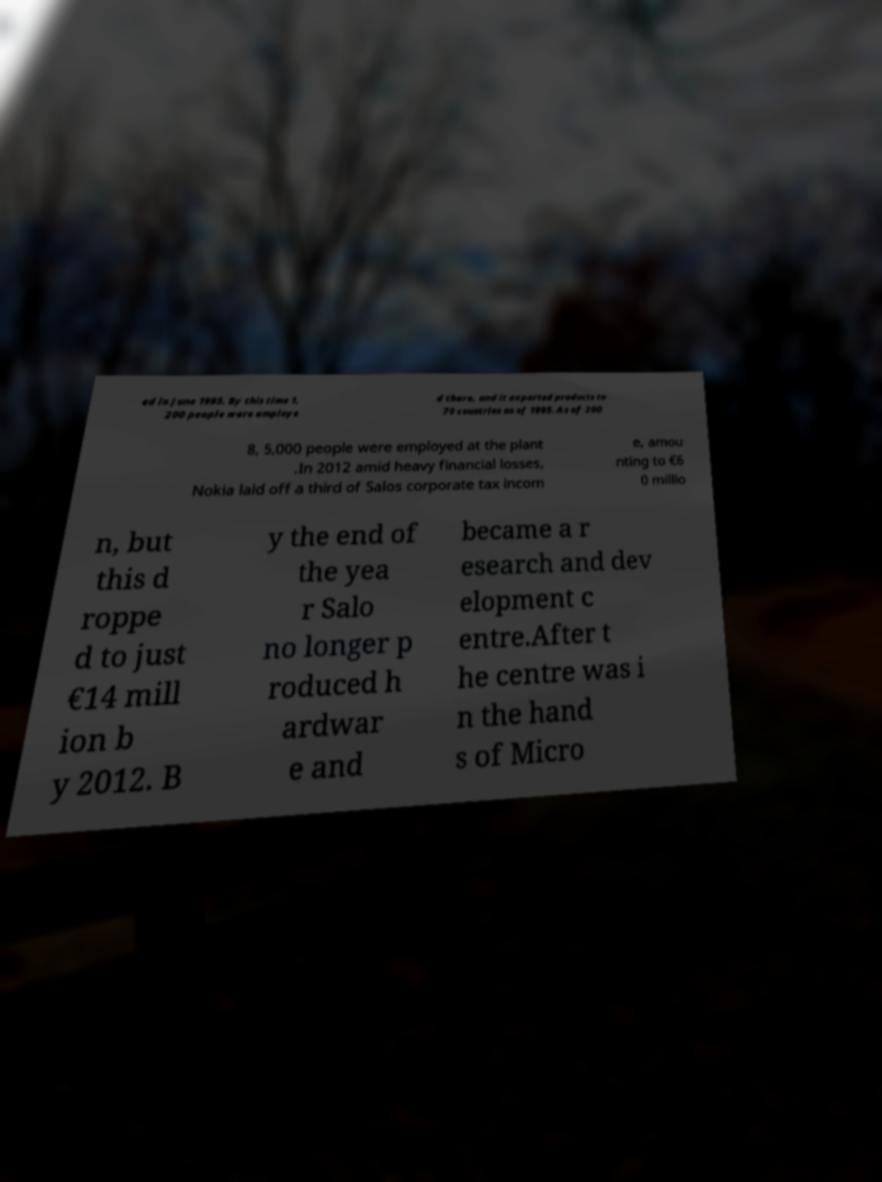What messages or text are displayed in this image? I need them in a readable, typed format. ed in June 1995. By this time 1, 200 people were employe d there, and it exported products to 70 countries as of 1995. As of 200 8, 5,000 people were employed at the plant .In 2012 amid heavy financial losses, Nokia laid off a third of Salos corporate tax incom e, amou nting to €6 0 millio n, but this d roppe d to just €14 mill ion b y 2012. B y the end of the yea r Salo no longer p roduced h ardwar e and became a r esearch and dev elopment c entre.After t he centre was i n the hand s of Micro 